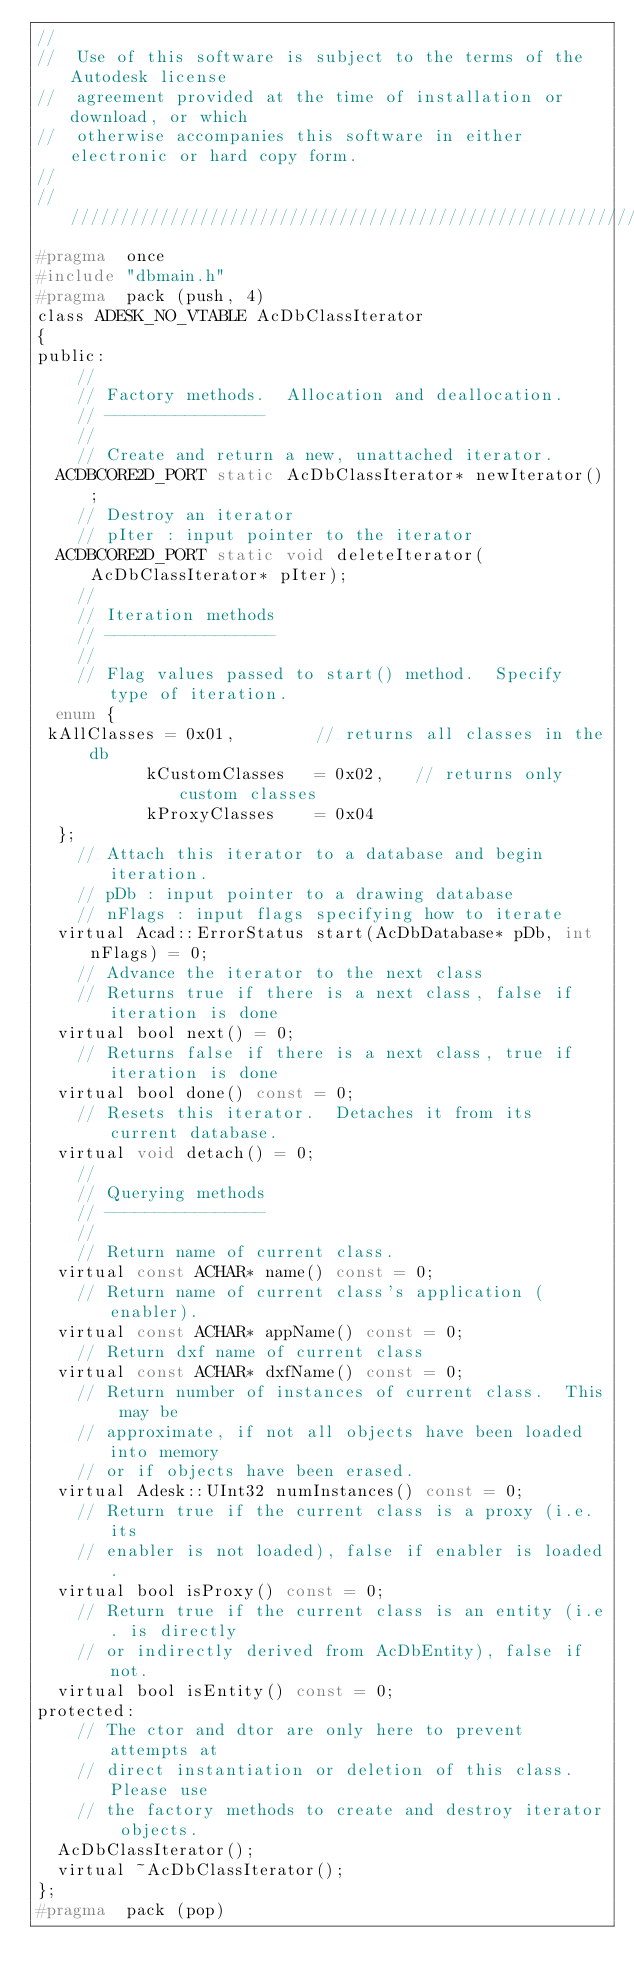<code> <loc_0><loc_0><loc_500><loc_500><_C_>//
//  Use of this software is subject to the terms of the Autodesk license 
//  agreement provided at the time of installation or download, or which 
//  otherwise accompanies this software in either electronic or hard copy form.   
//
//////////////////////////////////////////////////////////////////////////////
#pragma  once
#include "dbmain.h"
#pragma  pack (push, 4)
class ADESK_NO_VTABLE AcDbClassIterator
{
public:
    //
    // Factory methods.  Allocation and deallocation.
    // ----------------
    //
    // Create and return a new, unattached iterator.
  ACDBCORE2D_PORT static AcDbClassIterator* newIterator();
    // Destroy an iterator
    // pIter : input pointer to the iterator
  ACDBCORE2D_PORT static void deleteIterator(AcDbClassIterator* pIter);
    //
    // Iteration methods
    // -----------------
    //
    // Flag values passed to start() method.  Specify type of iteration.
  enum {
 kAllClasses = 0x01,        // returns all classes in the db
           kCustomClasses   = 0x02,   // returns only custom classes
           kProxyClasses    = 0x04
  };
    // Attach this iterator to a database and begin iteration.
    // pDb : input pointer to a drawing database
    // nFlags : input flags specifying how to iterate
  virtual Acad::ErrorStatus start(AcDbDatabase* pDb, int nFlags) = 0;
    // Advance the iterator to the next class
    // Returns true if there is a next class, false if iteration is done
  virtual bool next() = 0;
    // Returns false if there is a next class, true if iteration is done
  virtual bool done() const = 0;
    // Resets this iterator.  Detaches it from its current database.
  virtual void detach() = 0;
    //
    // Querying methods
    // ----------------
    //
    // Return name of current class.
  virtual const ACHAR* name() const = 0;
    // Return name of current class's application (enabler).
  virtual const ACHAR* appName() const = 0;
    // Return dxf name of current class
  virtual const ACHAR* dxfName() const = 0;
    // Return number of instances of current class.  This may be
    // approximate, if not all objects have been loaded into memory
    // or if objects have been erased.
  virtual Adesk::UInt32 numInstances() const = 0;
    // Return true if the current class is a proxy (i.e. its
    // enabler is not loaded), false if enabler is loaded.
  virtual bool isProxy() const = 0;
    // Return true if the current class is an entity (i.e. is directly
    // or indirectly derived from AcDbEntity), false if not.
  virtual bool isEntity() const = 0;
protected:
    // The ctor and dtor are only here to prevent attempts at
    // direct instantiation or deletion of this class.  Please use
    // the factory methods to create and destroy iterator objects.
  AcDbClassIterator();
  virtual ~AcDbClassIterator();
};
#pragma  pack (pop)
</code> 